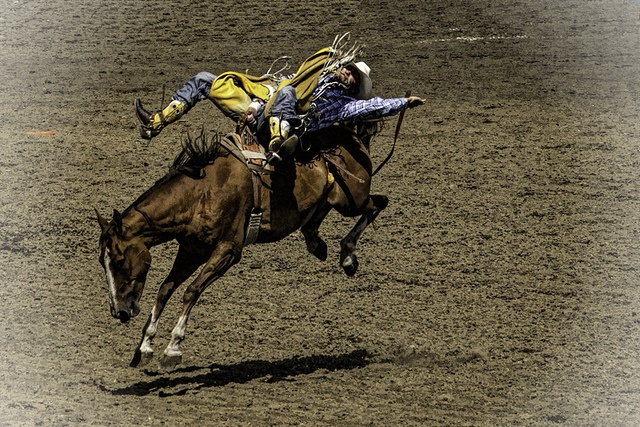Describe the objects in this image and their specific colors. I can see horse in darkgray, black, and gray tones and people in darkgray, black, gray, olive, and tan tones in this image. 